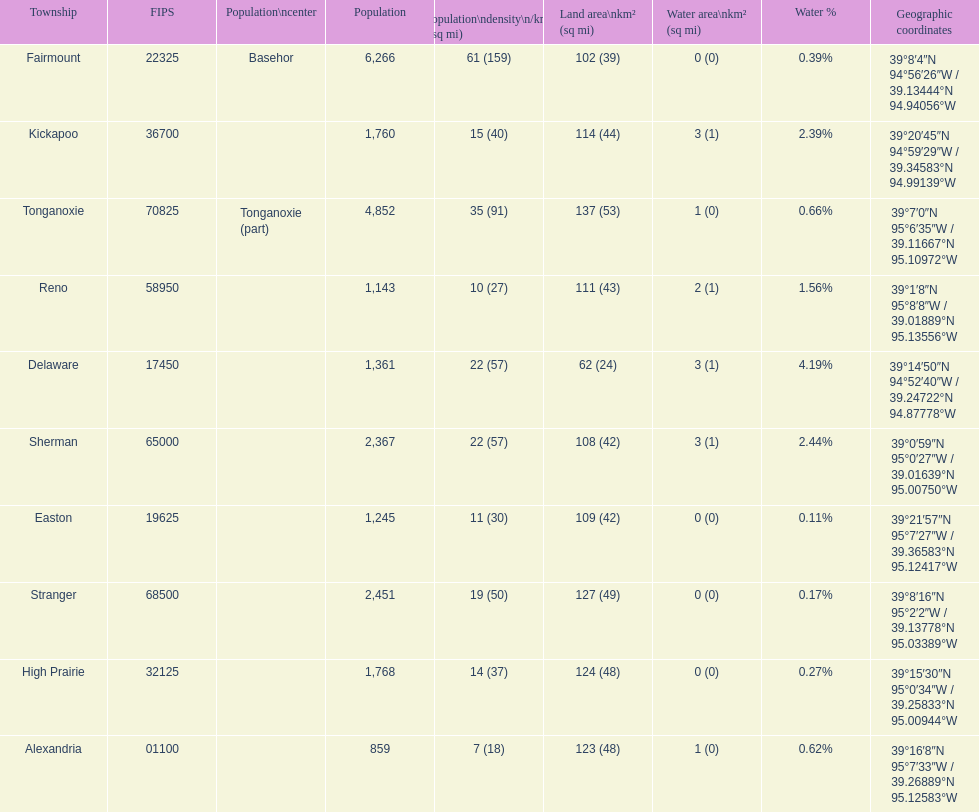What is the difference of population in easton and reno? 102. 